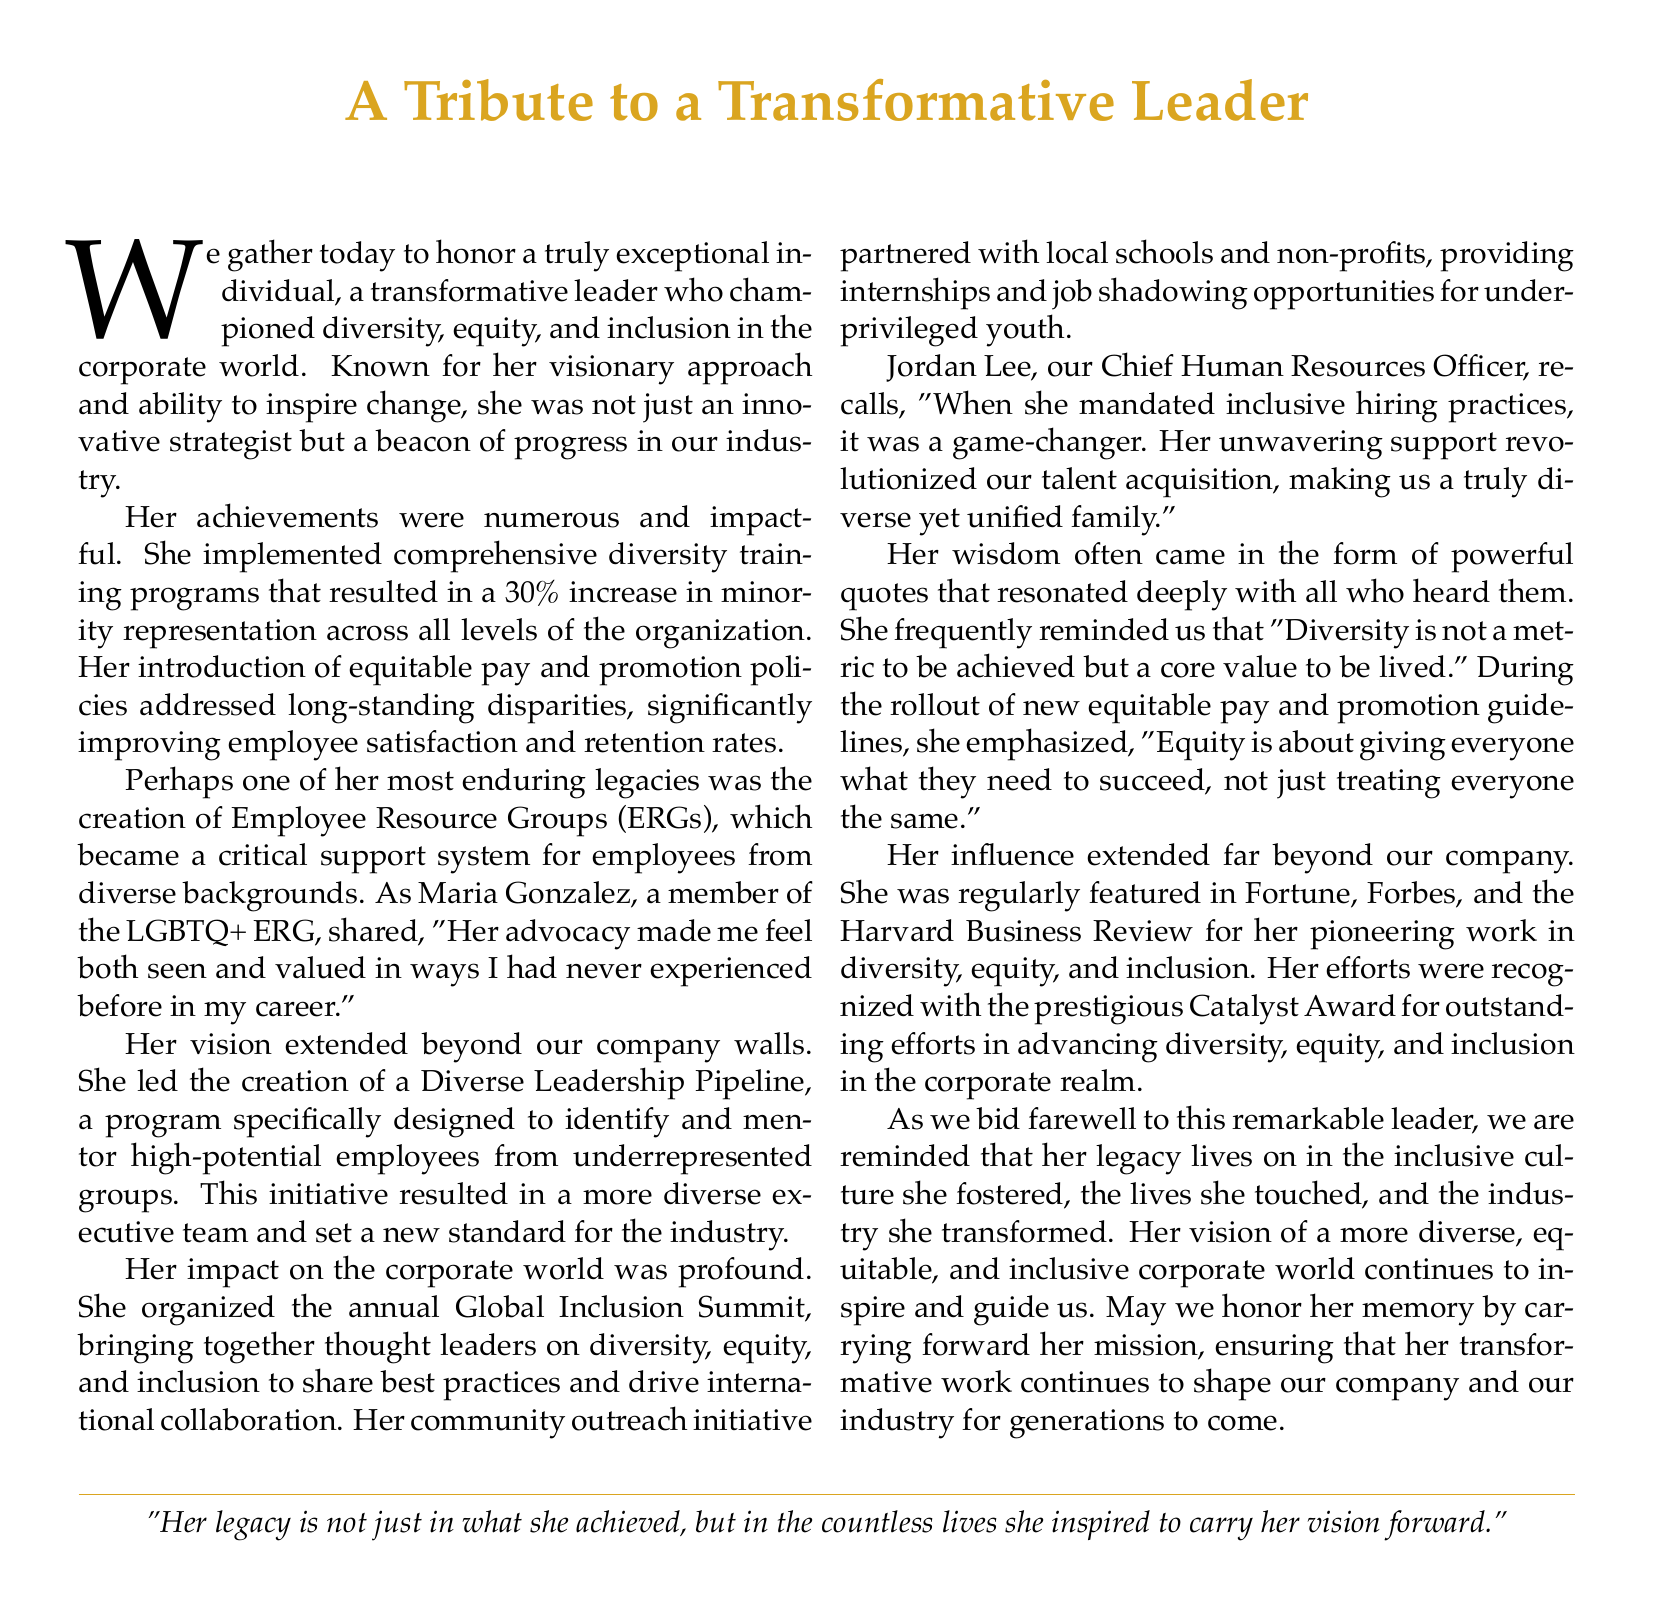What is the transformative leader known for? The document states that the leader was known for championing diversity, equity, and inclusion in the corporate world.
Answer: championing diversity, equity, and inclusion What percentage increase in minority representation was achieved? The document mentions a 30% increase in minority representation across all levels of the organization due to her initiatives.
Answer: 30% What was one of her most enduring legacies? The creation of Employee Resource Groups (ERGs) is highlighted as one of her most enduring legacies in the document.
Answer: Employee Resource Groups (ERGs) Who recognized her efforts with the Catalyst Award? The document specifically states that her efforts were recognized with the prestigious Catalyst Award for outstanding efforts in advancing diversity, equity, and inclusion.
Answer: Catalyst Award What did she frequently remind her team regarding diversity? She frequently reminded her team that "Diversity is not a metric to be achieved but a core value to be lived."
Answer: Diversity is not a metric to be achieved but a core value to be lived What program did she lead to mentor high-potential employees? The document describes the Diverse Leadership Pipeline program as the initiative she led to mentor high-potential employees from underrepresented groups.
Answer: Diverse Leadership Pipeline What impact did she have on talent acquisition? The Chief Human Resources Officer noted that her mandate on inclusive hiring practices revolutionized their talent acquisition.
Answer: revolutionized talent acquisition What was the aim of her community outreach initiative? The community outreach initiative aimed to provide internships and job shadowing opportunities for underprivileged youth.
Answer: provide internships and job shadowing opportunities What is said about her legacy? The document states that her legacy lives on in the inclusive culture she fostered and the lives she touched.
Answer: inclusive culture she fostered and the lives she touched 